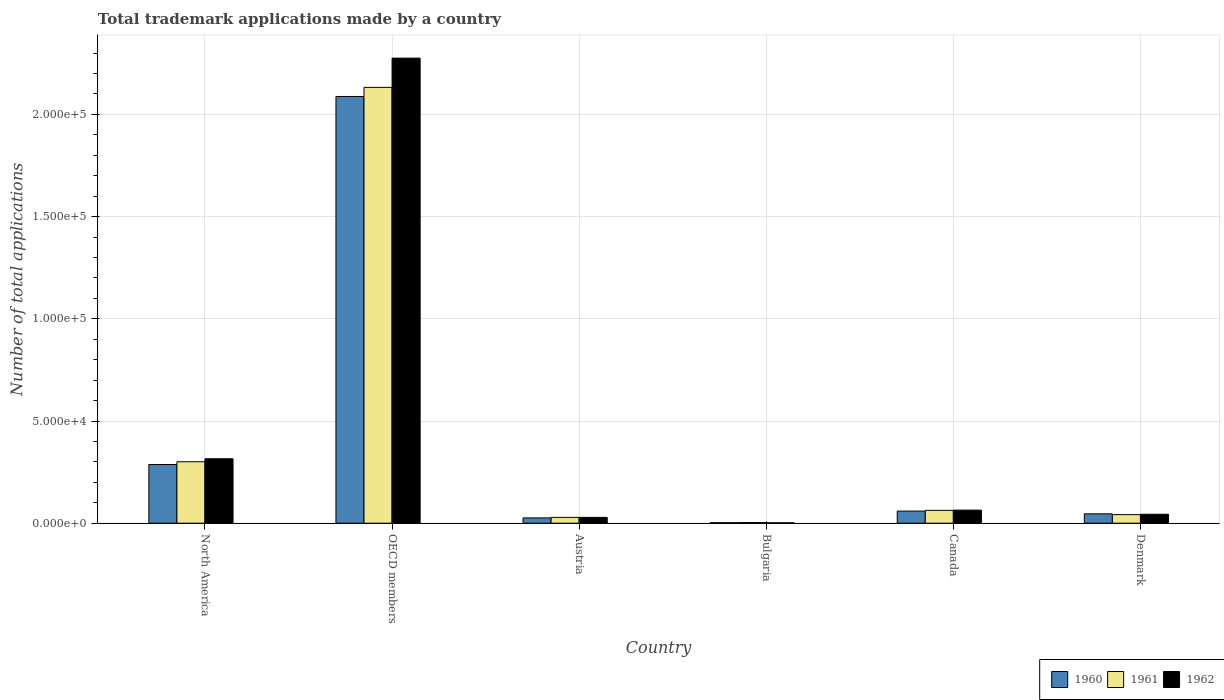How many different coloured bars are there?
Your answer should be very brief. 3. Are the number of bars per tick equal to the number of legend labels?
Offer a terse response. Yes. In how many cases, is the number of bars for a given country not equal to the number of legend labels?
Provide a short and direct response. 0. What is the number of applications made by in 1961 in Denmark?
Offer a very short reply. 4196. Across all countries, what is the maximum number of applications made by in 1960?
Your response must be concise. 2.09e+05. Across all countries, what is the minimum number of applications made by in 1960?
Ensure brevity in your answer.  250. In which country was the number of applications made by in 1960 maximum?
Your response must be concise. OECD members. What is the total number of applications made by in 1962 in the graph?
Make the answer very short. 2.73e+05. What is the difference between the number of applications made by in 1961 in Austria and that in Denmark?
Make the answer very short. -1344. What is the difference between the number of applications made by in 1961 in Canada and the number of applications made by in 1962 in Bulgaria?
Offer a very short reply. 6086. What is the average number of applications made by in 1960 per country?
Make the answer very short. 4.18e+04. What is the difference between the number of applications made by of/in 1962 and number of applications made by of/in 1960 in OECD members?
Offer a very short reply. 1.88e+04. In how many countries, is the number of applications made by in 1960 greater than 160000?
Make the answer very short. 1. What is the ratio of the number of applications made by in 1961 in Bulgaria to that in North America?
Your response must be concise. 0.01. What is the difference between the highest and the second highest number of applications made by in 1961?
Your answer should be very brief. -2.07e+05. What is the difference between the highest and the lowest number of applications made by in 1960?
Your answer should be compact. 2.09e+05. Is the sum of the number of applications made by in 1962 in Bulgaria and OECD members greater than the maximum number of applications made by in 1961 across all countries?
Make the answer very short. Yes. What does the 1st bar from the right in North America represents?
Your answer should be very brief. 1962. Is it the case that in every country, the sum of the number of applications made by in 1961 and number of applications made by in 1962 is greater than the number of applications made by in 1960?
Ensure brevity in your answer.  Yes. How many bars are there?
Offer a terse response. 18. Are all the bars in the graph horizontal?
Provide a succinct answer. No. How many countries are there in the graph?
Provide a short and direct response. 6. What is the difference between two consecutive major ticks on the Y-axis?
Offer a terse response. 5.00e+04. Are the values on the major ticks of Y-axis written in scientific E-notation?
Offer a terse response. Yes. Does the graph contain any zero values?
Give a very brief answer. No. Does the graph contain grids?
Ensure brevity in your answer.  Yes. What is the title of the graph?
Ensure brevity in your answer.  Total trademark applications made by a country. Does "1971" appear as one of the legend labels in the graph?
Your response must be concise. No. What is the label or title of the X-axis?
Make the answer very short. Country. What is the label or title of the Y-axis?
Your answer should be very brief. Number of total applications. What is the Number of total applications in 1960 in North America?
Provide a short and direct response. 2.87e+04. What is the Number of total applications in 1961 in North America?
Keep it short and to the point. 3.01e+04. What is the Number of total applications in 1962 in North America?
Give a very brief answer. 3.15e+04. What is the Number of total applications in 1960 in OECD members?
Your answer should be compact. 2.09e+05. What is the Number of total applications of 1961 in OECD members?
Offer a very short reply. 2.13e+05. What is the Number of total applications in 1962 in OECD members?
Offer a terse response. 2.28e+05. What is the Number of total applications of 1960 in Austria?
Give a very brief answer. 2596. What is the Number of total applications of 1961 in Austria?
Keep it short and to the point. 2852. What is the Number of total applications in 1962 in Austria?
Ensure brevity in your answer.  2849. What is the Number of total applications of 1960 in Bulgaria?
Ensure brevity in your answer.  250. What is the Number of total applications of 1961 in Bulgaria?
Offer a terse response. 318. What is the Number of total applications of 1962 in Bulgaria?
Offer a terse response. 195. What is the Number of total applications in 1960 in Canada?
Your answer should be very brief. 5927. What is the Number of total applications of 1961 in Canada?
Keep it short and to the point. 6281. What is the Number of total applications in 1962 in Canada?
Offer a very short reply. 6395. What is the Number of total applications of 1960 in Denmark?
Your answer should be very brief. 4584. What is the Number of total applications in 1961 in Denmark?
Provide a succinct answer. 4196. What is the Number of total applications of 1962 in Denmark?
Provide a succinct answer. 4380. Across all countries, what is the maximum Number of total applications in 1960?
Keep it short and to the point. 2.09e+05. Across all countries, what is the maximum Number of total applications in 1961?
Make the answer very short. 2.13e+05. Across all countries, what is the maximum Number of total applications in 1962?
Give a very brief answer. 2.28e+05. Across all countries, what is the minimum Number of total applications of 1960?
Keep it short and to the point. 250. Across all countries, what is the minimum Number of total applications in 1961?
Give a very brief answer. 318. Across all countries, what is the minimum Number of total applications in 1962?
Your answer should be compact. 195. What is the total Number of total applications of 1960 in the graph?
Ensure brevity in your answer.  2.51e+05. What is the total Number of total applications of 1961 in the graph?
Your response must be concise. 2.57e+05. What is the total Number of total applications in 1962 in the graph?
Offer a terse response. 2.73e+05. What is the difference between the Number of total applications in 1960 in North America and that in OECD members?
Provide a short and direct response. -1.80e+05. What is the difference between the Number of total applications in 1961 in North America and that in OECD members?
Your response must be concise. -1.83e+05. What is the difference between the Number of total applications in 1962 in North America and that in OECD members?
Offer a terse response. -1.96e+05. What is the difference between the Number of total applications in 1960 in North America and that in Austria?
Offer a terse response. 2.61e+04. What is the difference between the Number of total applications in 1961 in North America and that in Austria?
Offer a very short reply. 2.72e+04. What is the difference between the Number of total applications of 1962 in North America and that in Austria?
Make the answer very short. 2.87e+04. What is the difference between the Number of total applications in 1960 in North America and that in Bulgaria?
Make the answer very short. 2.85e+04. What is the difference between the Number of total applications of 1961 in North America and that in Bulgaria?
Your response must be concise. 2.97e+04. What is the difference between the Number of total applications of 1962 in North America and that in Bulgaria?
Your answer should be compact. 3.13e+04. What is the difference between the Number of total applications in 1960 in North America and that in Canada?
Make the answer very short. 2.28e+04. What is the difference between the Number of total applications of 1961 in North America and that in Canada?
Offer a very short reply. 2.38e+04. What is the difference between the Number of total applications in 1962 in North America and that in Canada?
Ensure brevity in your answer.  2.51e+04. What is the difference between the Number of total applications of 1960 in North America and that in Denmark?
Your response must be concise. 2.41e+04. What is the difference between the Number of total applications of 1961 in North America and that in Denmark?
Offer a very short reply. 2.59e+04. What is the difference between the Number of total applications of 1962 in North America and that in Denmark?
Your response must be concise. 2.71e+04. What is the difference between the Number of total applications in 1960 in OECD members and that in Austria?
Your answer should be very brief. 2.06e+05. What is the difference between the Number of total applications in 1961 in OECD members and that in Austria?
Provide a short and direct response. 2.10e+05. What is the difference between the Number of total applications in 1962 in OECD members and that in Austria?
Your answer should be very brief. 2.25e+05. What is the difference between the Number of total applications of 1960 in OECD members and that in Bulgaria?
Your answer should be very brief. 2.09e+05. What is the difference between the Number of total applications of 1961 in OECD members and that in Bulgaria?
Ensure brevity in your answer.  2.13e+05. What is the difference between the Number of total applications in 1962 in OECD members and that in Bulgaria?
Keep it short and to the point. 2.27e+05. What is the difference between the Number of total applications in 1960 in OECD members and that in Canada?
Make the answer very short. 2.03e+05. What is the difference between the Number of total applications of 1961 in OECD members and that in Canada?
Make the answer very short. 2.07e+05. What is the difference between the Number of total applications of 1962 in OECD members and that in Canada?
Give a very brief answer. 2.21e+05. What is the difference between the Number of total applications of 1960 in OECD members and that in Denmark?
Give a very brief answer. 2.04e+05. What is the difference between the Number of total applications of 1961 in OECD members and that in Denmark?
Keep it short and to the point. 2.09e+05. What is the difference between the Number of total applications in 1962 in OECD members and that in Denmark?
Your answer should be very brief. 2.23e+05. What is the difference between the Number of total applications of 1960 in Austria and that in Bulgaria?
Provide a succinct answer. 2346. What is the difference between the Number of total applications in 1961 in Austria and that in Bulgaria?
Your answer should be compact. 2534. What is the difference between the Number of total applications in 1962 in Austria and that in Bulgaria?
Keep it short and to the point. 2654. What is the difference between the Number of total applications of 1960 in Austria and that in Canada?
Make the answer very short. -3331. What is the difference between the Number of total applications of 1961 in Austria and that in Canada?
Provide a short and direct response. -3429. What is the difference between the Number of total applications in 1962 in Austria and that in Canada?
Your answer should be very brief. -3546. What is the difference between the Number of total applications in 1960 in Austria and that in Denmark?
Make the answer very short. -1988. What is the difference between the Number of total applications of 1961 in Austria and that in Denmark?
Keep it short and to the point. -1344. What is the difference between the Number of total applications in 1962 in Austria and that in Denmark?
Give a very brief answer. -1531. What is the difference between the Number of total applications of 1960 in Bulgaria and that in Canada?
Give a very brief answer. -5677. What is the difference between the Number of total applications in 1961 in Bulgaria and that in Canada?
Offer a terse response. -5963. What is the difference between the Number of total applications of 1962 in Bulgaria and that in Canada?
Your answer should be compact. -6200. What is the difference between the Number of total applications in 1960 in Bulgaria and that in Denmark?
Offer a terse response. -4334. What is the difference between the Number of total applications of 1961 in Bulgaria and that in Denmark?
Give a very brief answer. -3878. What is the difference between the Number of total applications in 1962 in Bulgaria and that in Denmark?
Offer a terse response. -4185. What is the difference between the Number of total applications in 1960 in Canada and that in Denmark?
Your answer should be very brief. 1343. What is the difference between the Number of total applications of 1961 in Canada and that in Denmark?
Provide a short and direct response. 2085. What is the difference between the Number of total applications in 1962 in Canada and that in Denmark?
Your response must be concise. 2015. What is the difference between the Number of total applications in 1960 in North America and the Number of total applications in 1961 in OECD members?
Ensure brevity in your answer.  -1.85e+05. What is the difference between the Number of total applications in 1960 in North America and the Number of total applications in 1962 in OECD members?
Make the answer very short. -1.99e+05. What is the difference between the Number of total applications of 1961 in North America and the Number of total applications of 1962 in OECD members?
Offer a terse response. -1.97e+05. What is the difference between the Number of total applications in 1960 in North America and the Number of total applications in 1961 in Austria?
Provide a short and direct response. 2.59e+04. What is the difference between the Number of total applications in 1960 in North America and the Number of total applications in 1962 in Austria?
Offer a terse response. 2.59e+04. What is the difference between the Number of total applications of 1961 in North America and the Number of total applications of 1962 in Austria?
Ensure brevity in your answer.  2.72e+04. What is the difference between the Number of total applications in 1960 in North America and the Number of total applications in 1961 in Bulgaria?
Your response must be concise. 2.84e+04. What is the difference between the Number of total applications in 1960 in North America and the Number of total applications in 1962 in Bulgaria?
Make the answer very short. 2.85e+04. What is the difference between the Number of total applications in 1961 in North America and the Number of total applications in 1962 in Bulgaria?
Make the answer very short. 2.99e+04. What is the difference between the Number of total applications of 1960 in North America and the Number of total applications of 1961 in Canada?
Your response must be concise. 2.24e+04. What is the difference between the Number of total applications of 1960 in North America and the Number of total applications of 1962 in Canada?
Offer a terse response. 2.23e+04. What is the difference between the Number of total applications in 1961 in North America and the Number of total applications in 1962 in Canada?
Make the answer very short. 2.37e+04. What is the difference between the Number of total applications of 1960 in North America and the Number of total applications of 1961 in Denmark?
Provide a short and direct response. 2.45e+04. What is the difference between the Number of total applications in 1960 in North America and the Number of total applications in 1962 in Denmark?
Make the answer very short. 2.43e+04. What is the difference between the Number of total applications in 1961 in North America and the Number of total applications in 1962 in Denmark?
Your answer should be compact. 2.57e+04. What is the difference between the Number of total applications in 1960 in OECD members and the Number of total applications in 1961 in Austria?
Provide a short and direct response. 2.06e+05. What is the difference between the Number of total applications of 1960 in OECD members and the Number of total applications of 1962 in Austria?
Offer a terse response. 2.06e+05. What is the difference between the Number of total applications in 1961 in OECD members and the Number of total applications in 1962 in Austria?
Your answer should be compact. 2.10e+05. What is the difference between the Number of total applications of 1960 in OECD members and the Number of total applications of 1961 in Bulgaria?
Make the answer very short. 2.08e+05. What is the difference between the Number of total applications of 1960 in OECD members and the Number of total applications of 1962 in Bulgaria?
Ensure brevity in your answer.  2.09e+05. What is the difference between the Number of total applications in 1961 in OECD members and the Number of total applications in 1962 in Bulgaria?
Ensure brevity in your answer.  2.13e+05. What is the difference between the Number of total applications in 1960 in OECD members and the Number of total applications in 1961 in Canada?
Your answer should be very brief. 2.02e+05. What is the difference between the Number of total applications in 1960 in OECD members and the Number of total applications in 1962 in Canada?
Give a very brief answer. 2.02e+05. What is the difference between the Number of total applications in 1961 in OECD members and the Number of total applications in 1962 in Canada?
Offer a terse response. 2.07e+05. What is the difference between the Number of total applications of 1960 in OECD members and the Number of total applications of 1961 in Denmark?
Give a very brief answer. 2.05e+05. What is the difference between the Number of total applications of 1960 in OECD members and the Number of total applications of 1962 in Denmark?
Offer a terse response. 2.04e+05. What is the difference between the Number of total applications in 1961 in OECD members and the Number of total applications in 1962 in Denmark?
Keep it short and to the point. 2.09e+05. What is the difference between the Number of total applications of 1960 in Austria and the Number of total applications of 1961 in Bulgaria?
Give a very brief answer. 2278. What is the difference between the Number of total applications of 1960 in Austria and the Number of total applications of 1962 in Bulgaria?
Offer a very short reply. 2401. What is the difference between the Number of total applications in 1961 in Austria and the Number of total applications in 1962 in Bulgaria?
Offer a terse response. 2657. What is the difference between the Number of total applications in 1960 in Austria and the Number of total applications in 1961 in Canada?
Provide a succinct answer. -3685. What is the difference between the Number of total applications of 1960 in Austria and the Number of total applications of 1962 in Canada?
Your answer should be very brief. -3799. What is the difference between the Number of total applications in 1961 in Austria and the Number of total applications in 1962 in Canada?
Provide a succinct answer. -3543. What is the difference between the Number of total applications of 1960 in Austria and the Number of total applications of 1961 in Denmark?
Ensure brevity in your answer.  -1600. What is the difference between the Number of total applications in 1960 in Austria and the Number of total applications in 1962 in Denmark?
Offer a very short reply. -1784. What is the difference between the Number of total applications of 1961 in Austria and the Number of total applications of 1962 in Denmark?
Offer a terse response. -1528. What is the difference between the Number of total applications of 1960 in Bulgaria and the Number of total applications of 1961 in Canada?
Offer a terse response. -6031. What is the difference between the Number of total applications in 1960 in Bulgaria and the Number of total applications in 1962 in Canada?
Keep it short and to the point. -6145. What is the difference between the Number of total applications in 1961 in Bulgaria and the Number of total applications in 1962 in Canada?
Make the answer very short. -6077. What is the difference between the Number of total applications in 1960 in Bulgaria and the Number of total applications in 1961 in Denmark?
Your answer should be very brief. -3946. What is the difference between the Number of total applications in 1960 in Bulgaria and the Number of total applications in 1962 in Denmark?
Your response must be concise. -4130. What is the difference between the Number of total applications in 1961 in Bulgaria and the Number of total applications in 1962 in Denmark?
Offer a terse response. -4062. What is the difference between the Number of total applications of 1960 in Canada and the Number of total applications of 1961 in Denmark?
Make the answer very short. 1731. What is the difference between the Number of total applications in 1960 in Canada and the Number of total applications in 1962 in Denmark?
Offer a very short reply. 1547. What is the difference between the Number of total applications in 1961 in Canada and the Number of total applications in 1962 in Denmark?
Your answer should be compact. 1901. What is the average Number of total applications of 1960 per country?
Keep it short and to the point. 4.18e+04. What is the average Number of total applications of 1961 per country?
Provide a short and direct response. 4.28e+04. What is the average Number of total applications of 1962 per country?
Provide a short and direct response. 4.55e+04. What is the difference between the Number of total applications of 1960 and Number of total applications of 1961 in North America?
Your response must be concise. -1355. What is the difference between the Number of total applications of 1960 and Number of total applications of 1962 in North America?
Make the answer very short. -2817. What is the difference between the Number of total applications in 1961 and Number of total applications in 1962 in North America?
Your answer should be compact. -1462. What is the difference between the Number of total applications of 1960 and Number of total applications of 1961 in OECD members?
Give a very brief answer. -4452. What is the difference between the Number of total applications of 1960 and Number of total applications of 1962 in OECD members?
Your answer should be compact. -1.88e+04. What is the difference between the Number of total applications in 1961 and Number of total applications in 1962 in OECD members?
Your answer should be compact. -1.43e+04. What is the difference between the Number of total applications in 1960 and Number of total applications in 1961 in Austria?
Your response must be concise. -256. What is the difference between the Number of total applications of 1960 and Number of total applications of 1962 in Austria?
Your answer should be very brief. -253. What is the difference between the Number of total applications of 1960 and Number of total applications of 1961 in Bulgaria?
Your answer should be very brief. -68. What is the difference between the Number of total applications of 1960 and Number of total applications of 1962 in Bulgaria?
Your response must be concise. 55. What is the difference between the Number of total applications in 1961 and Number of total applications in 1962 in Bulgaria?
Your answer should be very brief. 123. What is the difference between the Number of total applications in 1960 and Number of total applications in 1961 in Canada?
Your answer should be very brief. -354. What is the difference between the Number of total applications in 1960 and Number of total applications in 1962 in Canada?
Your answer should be very brief. -468. What is the difference between the Number of total applications in 1961 and Number of total applications in 1962 in Canada?
Your answer should be very brief. -114. What is the difference between the Number of total applications of 1960 and Number of total applications of 1961 in Denmark?
Ensure brevity in your answer.  388. What is the difference between the Number of total applications of 1960 and Number of total applications of 1962 in Denmark?
Keep it short and to the point. 204. What is the difference between the Number of total applications in 1961 and Number of total applications in 1962 in Denmark?
Give a very brief answer. -184. What is the ratio of the Number of total applications of 1960 in North America to that in OECD members?
Offer a terse response. 0.14. What is the ratio of the Number of total applications in 1961 in North America to that in OECD members?
Ensure brevity in your answer.  0.14. What is the ratio of the Number of total applications of 1962 in North America to that in OECD members?
Keep it short and to the point. 0.14. What is the ratio of the Number of total applications in 1960 in North America to that in Austria?
Offer a very short reply. 11.06. What is the ratio of the Number of total applications in 1961 in North America to that in Austria?
Your answer should be compact. 10.54. What is the ratio of the Number of total applications in 1962 in North America to that in Austria?
Keep it short and to the point. 11.07. What is the ratio of the Number of total applications in 1960 in North America to that in Bulgaria?
Your answer should be very brief. 114.83. What is the ratio of the Number of total applications of 1961 in North America to that in Bulgaria?
Provide a succinct answer. 94.54. What is the ratio of the Number of total applications in 1962 in North America to that in Bulgaria?
Your answer should be compact. 161.67. What is the ratio of the Number of total applications in 1960 in North America to that in Canada?
Provide a short and direct response. 4.84. What is the ratio of the Number of total applications of 1961 in North America to that in Canada?
Your response must be concise. 4.79. What is the ratio of the Number of total applications of 1962 in North America to that in Canada?
Your answer should be compact. 4.93. What is the ratio of the Number of total applications of 1960 in North America to that in Denmark?
Your response must be concise. 6.26. What is the ratio of the Number of total applications in 1961 in North America to that in Denmark?
Your answer should be compact. 7.16. What is the ratio of the Number of total applications in 1962 in North America to that in Denmark?
Make the answer very short. 7.2. What is the ratio of the Number of total applications of 1960 in OECD members to that in Austria?
Provide a succinct answer. 80.42. What is the ratio of the Number of total applications in 1961 in OECD members to that in Austria?
Keep it short and to the point. 74.76. What is the ratio of the Number of total applications in 1962 in OECD members to that in Austria?
Provide a succinct answer. 79.86. What is the ratio of the Number of total applications in 1960 in OECD members to that in Bulgaria?
Offer a very short reply. 835.08. What is the ratio of the Number of total applications of 1961 in OECD members to that in Bulgaria?
Provide a short and direct response. 670.51. What is the ratio of the Number of total applications in 1962 in OECD members to that in Bulgaria?
Provide a succinct answer. 1166.82. What is the ratio of the Number of total applications of 1960 in OECD members to that in Canada?
Offer a terse response. 35.22. What is the ratio of the Number of total applications in 1961 in OECD members to that in Canada?
Ensure brevity in your answer.  33.95. What is the ratio of the Number of total applications of 1962 in OECD members to that in Canada?
Give a very brief answer. 35.58. What is the ratio of the Number of total applications in 1960 in OECD members to that in Denmark?
Your answer should be very brief. 45.54. What is the ratio of the Number of total applications in 1961 in OECD members to that in Denmark?
Offer a terse response. 50.82. What is the ratio of the Number of total applications of 1962 in OECD members to that in Denmark?
Your response must be concise. 51.95. What is the ratio of the Number of total applications of 1960 in Austria to that in Bulgaria?
Offer a very short reply. 10.38. What is the ratio of the Number of total applications of 1961 in Austria to that in Bulgaria?
Make the answer very short. 8.97. What is the ratio of the Number of total applications in 1962 in Austria to that in Bulgaria?
Your answer should be compact. 14.61. What is the ratio of the Number of total applications in 1960 in Austria to that in Canada?
Offer a terse response. 0.44. What is the ratio of the Number of total applications of 1961 in Austria to that in Canada?
Give a very brief answer. 0.45. What is the ratio of the Number of total applications of 1962 in Austria to that in Canada?
Offer a terse response. 0.45. What is the ratio of the Number of total applications in 1960 in Austria to that in Denmark?
Offer a terse response. 0.57. What is the ratio of the Number of total applications in 1961 in Austria to that in Denmark?
Your response must be concise. 0.68. What is the ratio of the Number of total applications in 1962 in Austria to that in Denmark?
Give a very brief answer. 0.65. What is the ratio of the Number of total applications of 1960 in Bulgaria to that in Canada?
Provide a short and direct response. 0.04. What is the ratio of the Number of total applications of 1961 in Bulgaria to that in Canada?
Offer a terse response. 0.05. What is the ratio of the Number of total applications in 1962 in Bulgaria to that in Canada?
Provide a succinct answer. 0.03. What is the ratio of the Number of total applications of 1960 in Bulgaria to that in Denmark?
Give a very brief answer. 0.05. What is the ratio of the Number of total applications in 1961 in Bulgaria to that in Denmark?
Offer a very short reply. 0.08. What is the ratio of the Number of total applications in 1962 in Bulgaria to that in Denmark?
Ensure brevity in your answer.  0.04. What is the ratio of the Number of total applications in 1960 in Canada to that in Denmark?
Keep it short and to the point. 1.29. What is the ratio of the Number of total applications of 1961 in Canada to that in Denmark?
Provide a short and direct response. 1.5. What is the ratio of the Number of total applications of 1962 in Canada to that in Denmark?
Keep it short and to the point. 1.46. What is the difference between the highest and the second highest Number of total applications of 1960?
Make the answer very short. 1.80e+05. What is the difference between the highest and the second highest Number of total applications of 1961?
Give a very brief answer. 1.83e+05. What is the difference between the highest and the second highest Number of total applications in 1962?
Ensure brevity in your answer.  1.96e+05. What is the difference between the highest and the lowest Number of total applications in 1960?
Provide a succinct answer. 2.09e+05. What is the difference between the highest and the lowest Number of total applications in 1961?
Your answer should be compact. 2.13e+05. What is the difference between the highest and the lowest Number of total applications in 1962?
Make the answer very short. 2.27e+05. 